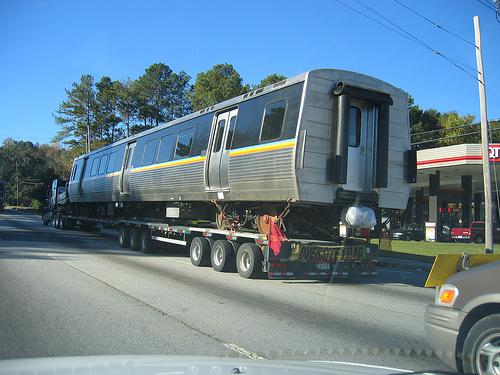Question: what is the 18 wheeler hauling?
Choices:
A. Telephone poles.
B. Truck bodies.
C. Turbines.
D. A train car.
Answer with the letter. Answer: D Question: what does the yellow sign say?
Choices:
A. Over size load.
B. Caution.
C. Yield.
D. Construction Ahead.
Answer with the letter. Answer: A Question: how many train cars are there?
Choices:
A. 3.
B. 4.
C. 5.
D. 1.
Answer with the letter. Answer: D 